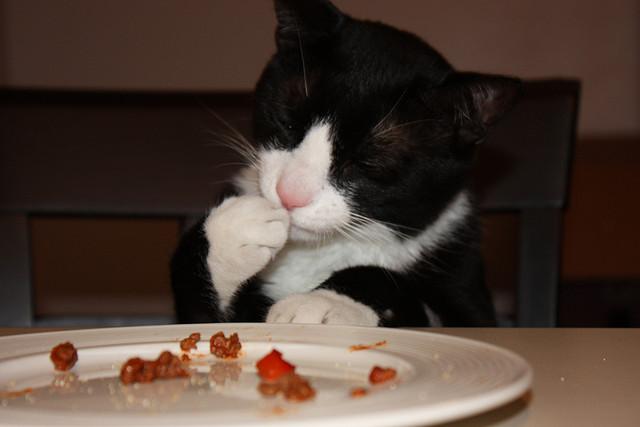What cat is this?
Quick response, please. Black and white. Is the cat about to pounce?
Give a very brief answer. No. Where is the cat in this photo?
Short answer required. In chair. Is this normally the way a cat eats?
Keep it brief. No. 